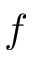<formula> <loc_0><loc_0><loc_500><loc_500>f</formula> 